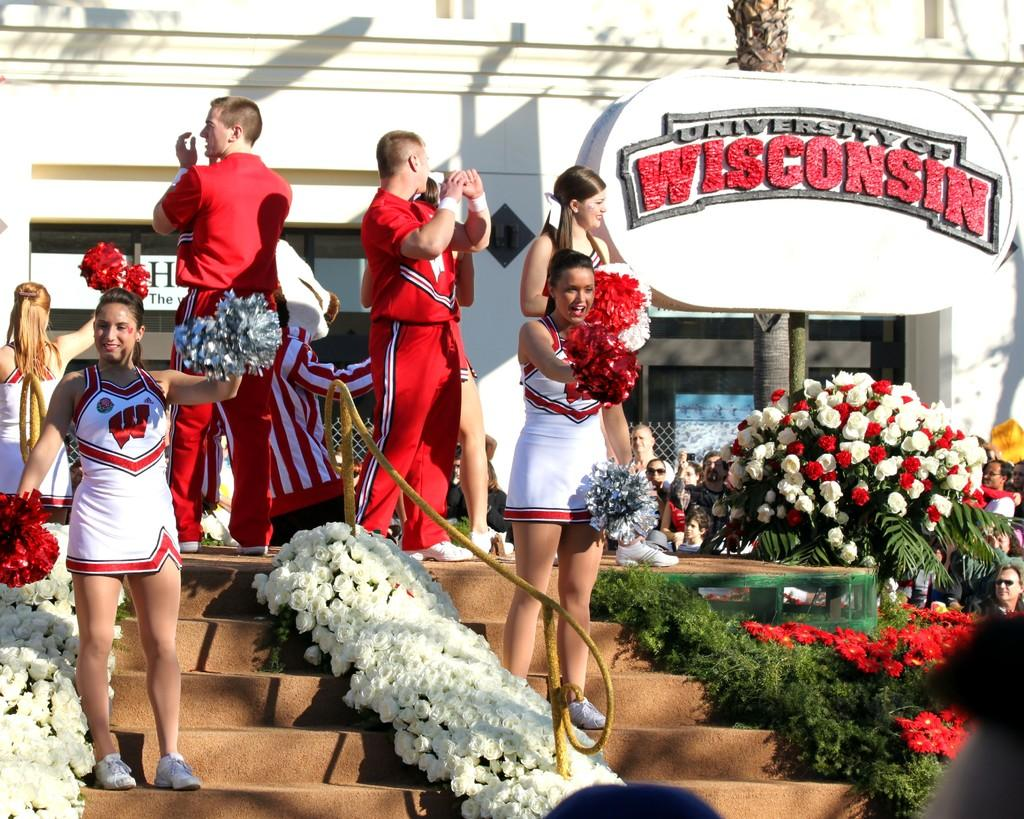<image>
Describe the image concisely. the students of University of Wisconsin celebrating an event 